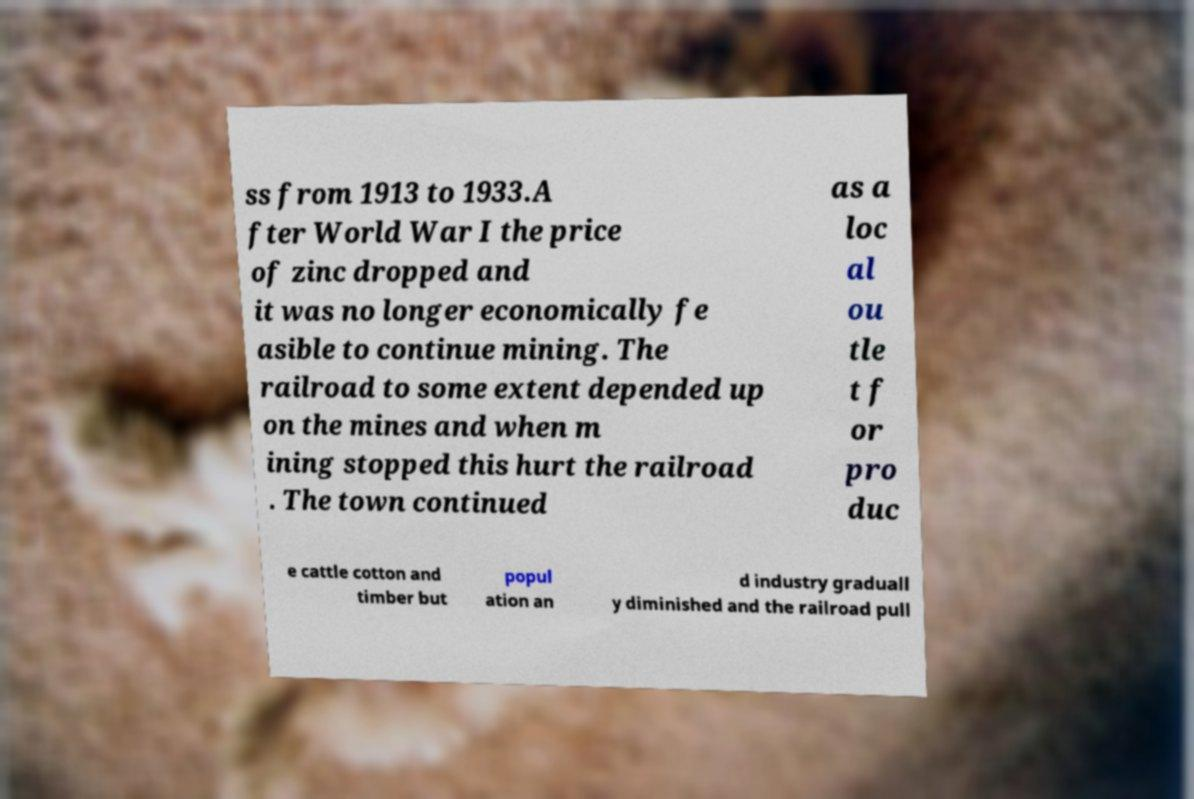There's text embedded in this image that I need extracted. Can you transcribe it verbatim? ss from 1913 to 1933.A fter World War I the price of zinc dropped and it was no longer economically fe asible to continue mining. The railroad to some extent depended up on the mines and when m ining stopped this hurt the railroad . The town continued as a loc al ou tle t f or pro duc e cattle cotton and timber but popul ation an d industry graduall y diminished and the railroad pull 